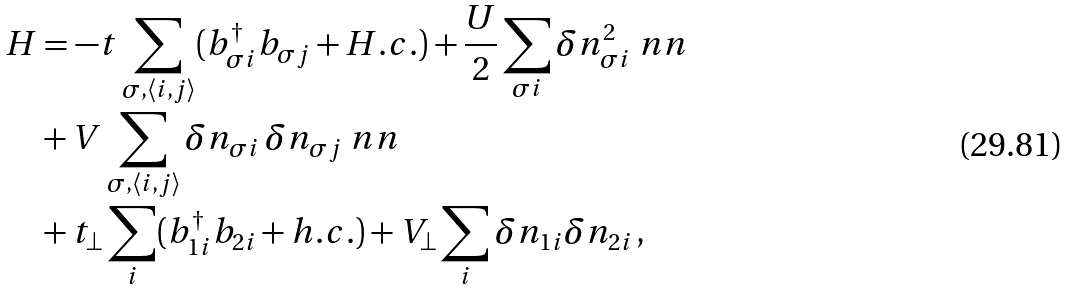Convert formula to latex. <formula><loc_0><loc_0><loc_500><loc_500>H & = - t \sum _ { \sigma , \langle i , j \rangle } ( b _ { \sigma i } ^ { \dag } b _ { \sigma j } + H . c . ) + \frac { U } { 2 } \sum _ { \sigma i } \delta n _ { \sigma i } ^ { 2 } \ n n \\ & + V \sum _ { \sigma , \langle i , j \rangle } \delta n _ { \sigma i } \, \delta n _ { \sigma j } \ n n \\ & + t _ { \perp } \sum _ { i } ( b _ { 1 i } ^ { \dagger } b _ { 2 i } + h . c . ) + V _ { \perp } \sum _ { i } \delta n _ { 1 i } \delta n _ { 2 i } \, ,</formula> 